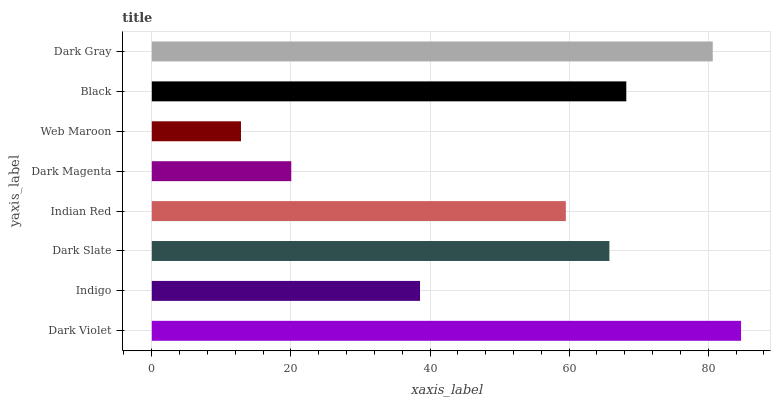Is Web Maroon the minimum?
Answer yes or no. Yes. Is Dark Violet the maximum?
Answer yes or no. Yes. Is Indigo the minimum?
Answer yes or no. No. Is Indigo the maximum?
Answer yes or no. No. Is Dark Violet greater than Indigo?
Answer yes or no. Yes. Is Indigo less than Dark Violet?
Answer yes or no. Yes. Is Indigo greater than Dark Violet?
Answer yes or no. No. Is Dark Violet less than Indigo?
Answer yes or no. No. Is Dark Slate the high median?
Answer yes or no. Yes. Is Indian Red the low median?
Answer yes or no. Yes. Is Indigo the high median?
Answer yes or no. No. Is Indigo the low median?
Answer yes or no. No. 